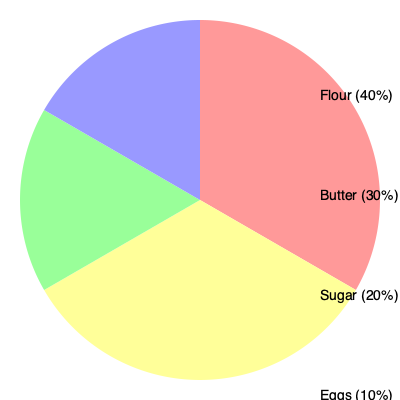In the classic Croatian pastry recipe shown in the pie chart, what is the ratio of flour to sugar? To find the ratio of flour to sugar in the classic Croatian pastry recipe, we need to follow these steps:

1. Identify the percentages for flour and sugar from the pie chart:
   - Flour: 40%
   - Sugar: 20%

2. Express the percentages as fractions:
   - Flour: $\frac{40}{100}$ or $\frac{2}{5}$
   - Sugar: $\frac{20}{100}$ or $\frac{1}{5}$

3. Set up the ratio of flour to sugar:
   $\frac{\text{Flour}}{\text{Sugar}} = \frac{\frac{2}{5}}{\frac{1}{5}}$

4. Simplify the ratio by dividing the numerator and denominator by their greatest common factor:
   $\frac{\frac{2}{5}}{\frac{1}{5}} = \frac{2}{1} = 2:1$

Therefore, the ratio of flour to sugar in the classic Croatian pastry recipe is 2:1.
Answer: 2:1 